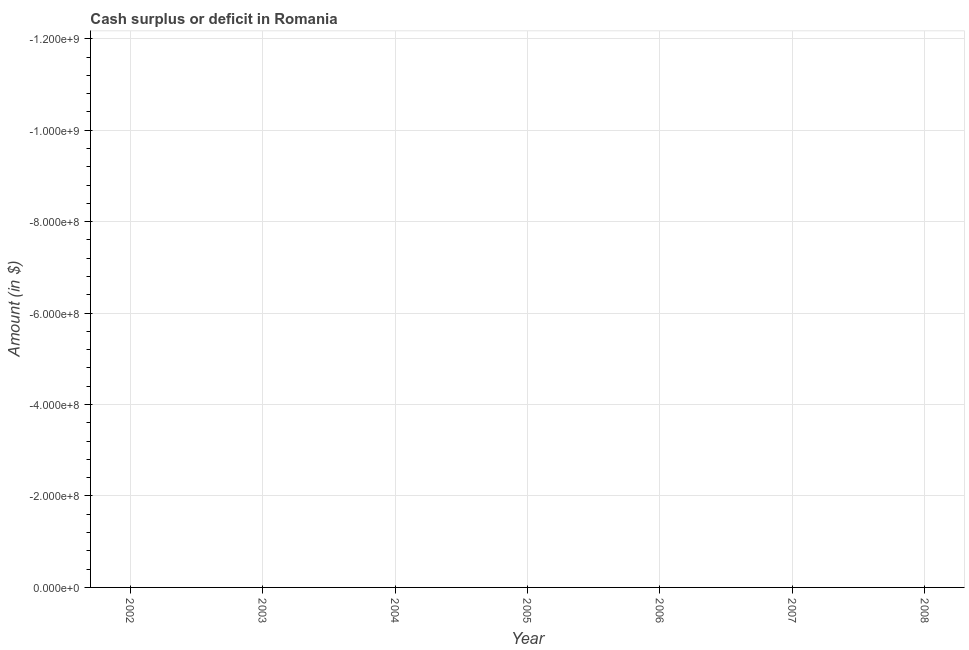What is the sum of the cash surplus or deficit?
Your response must be concise. 0. What is the average cash surplus or deficit per year?
Your response must be concise. 0. In how many years, is the cash surplus or deficit greater than -1080000000 $?
Ensure brevity in your answer.  0. Does the cash surplus or deficit monotonically increase over the years?
Offer a very short reply. No. How many years are there in the graph?
Make the answer very short. 7. Does the graph contain any zero values?
Keep it short and to the point. Yes. What is the title of the graph?
Make the answer very short. Cash surplus or deficit in Romania. What is the label or title of the X-axis?
Offer a very short reply. Year. What is the label or title of the Y-axis?
Offer a terse response. Amount (in $). What is the Amount (in $) in 2002?
Offer a terse response. 0. What is the Amount (in $) in 2003?
Your answer should be compact. 0. What is the Amount (in $) in 2004?
Your answer should be compact. 0. What is the Amount (in $) in 2006?
Provide a succinct answer. 0. What is the Amount (in $) in 2007?
Offer a terse response. 0. What is the Amount (in $) in 2008?
Ensure brevity in your answer.  0. 